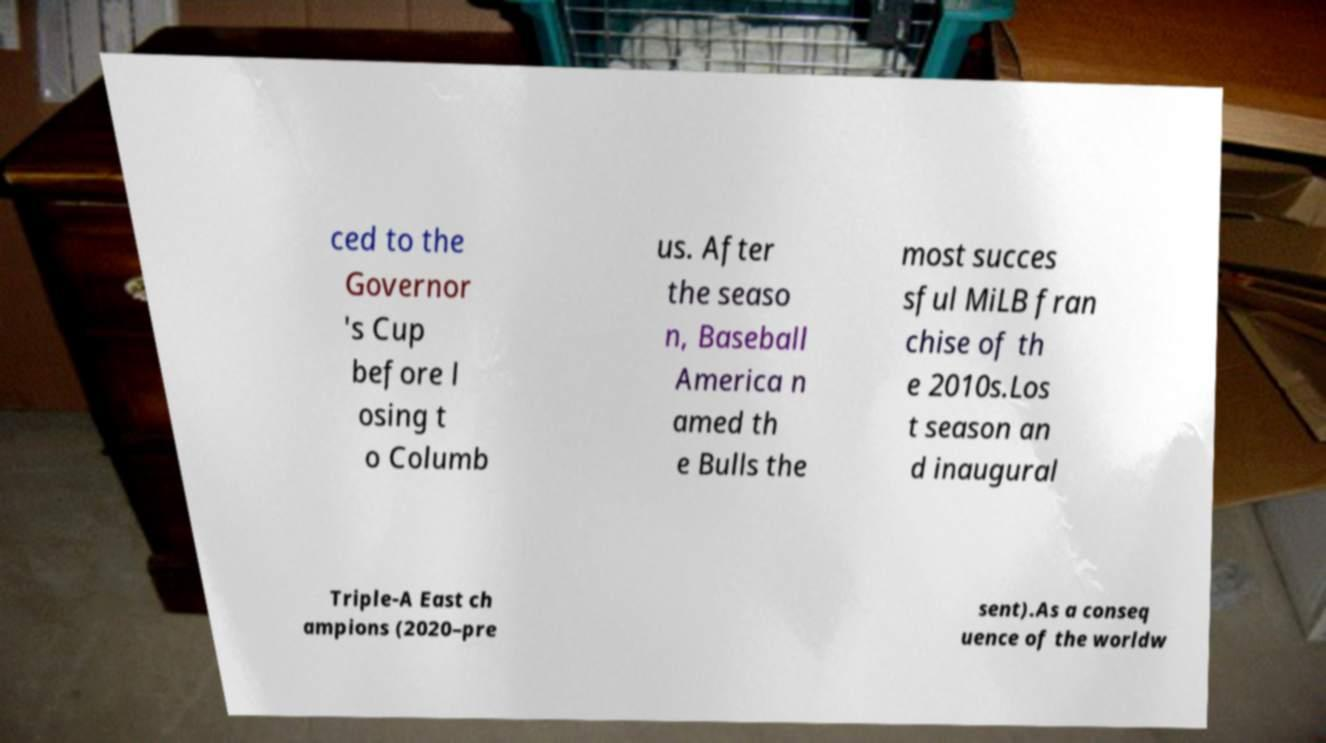Could you assist in decoding the text presented in this image and type it out clearly? ced to the Governor 's Cup before l osing t o Columb us. After the seaso n, Baseball America n amed th e Bulls the most succes sful MiLB fran chise of th e 2010s.Los t season an d inaugural Triple-A East ch ampions (2020–pre sent).As a conseq uence of the worldw 